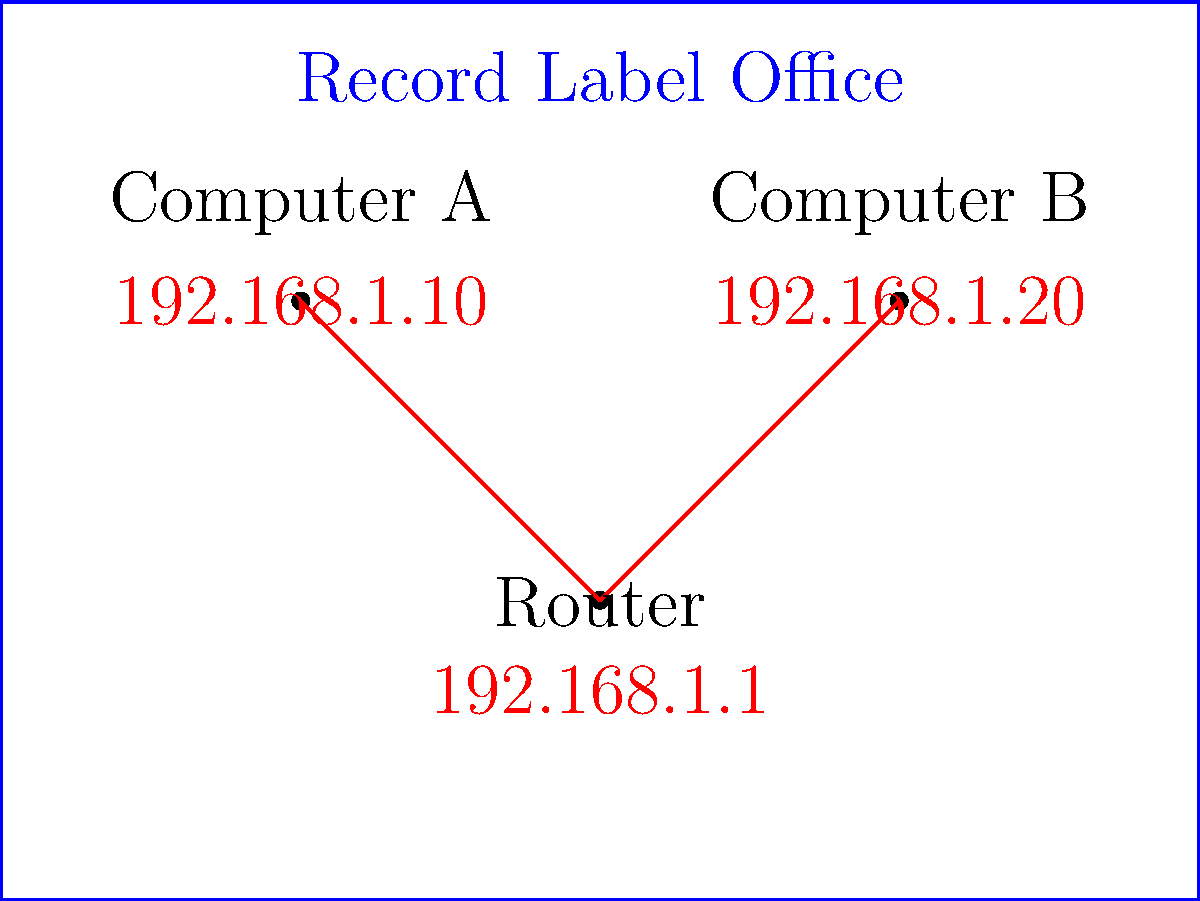At your dream record label's office, you notice their simple network setup. If Computer A wants to send a demo of your latest country song to Computer B, what will be the destination IP address in the packet header? Let's break this down step-by-step:

1. In a local network, devices communicate directly using their assigned IP addresses.

2. Looking at the network diagram, we can see:
   - Computer A has IP address 192.168.1.10
   - Computer B has IP address 192.168.1.20
   - The Router has IP address 192.168.1.1

3. When Computer A wants to send data to Computer B, it needs to address the packet directly to Computer B's IP address.

4. In this case, Computer B's IP address is 192.168.1.20.

5. The router (192.168.1.1) is only used when sending data outside the local network. For communication within the same network, devices can communicate directly.

6. Therefore, when Computer A sends the demo to Computer B, it will use Computer B's IP address (192.168.1.20) as the destination in the packet header.

This setup is similar to how you might share your music files with band members in a small studio network before sending them out to bigger record labels!
Answer: 192.168.1.20 